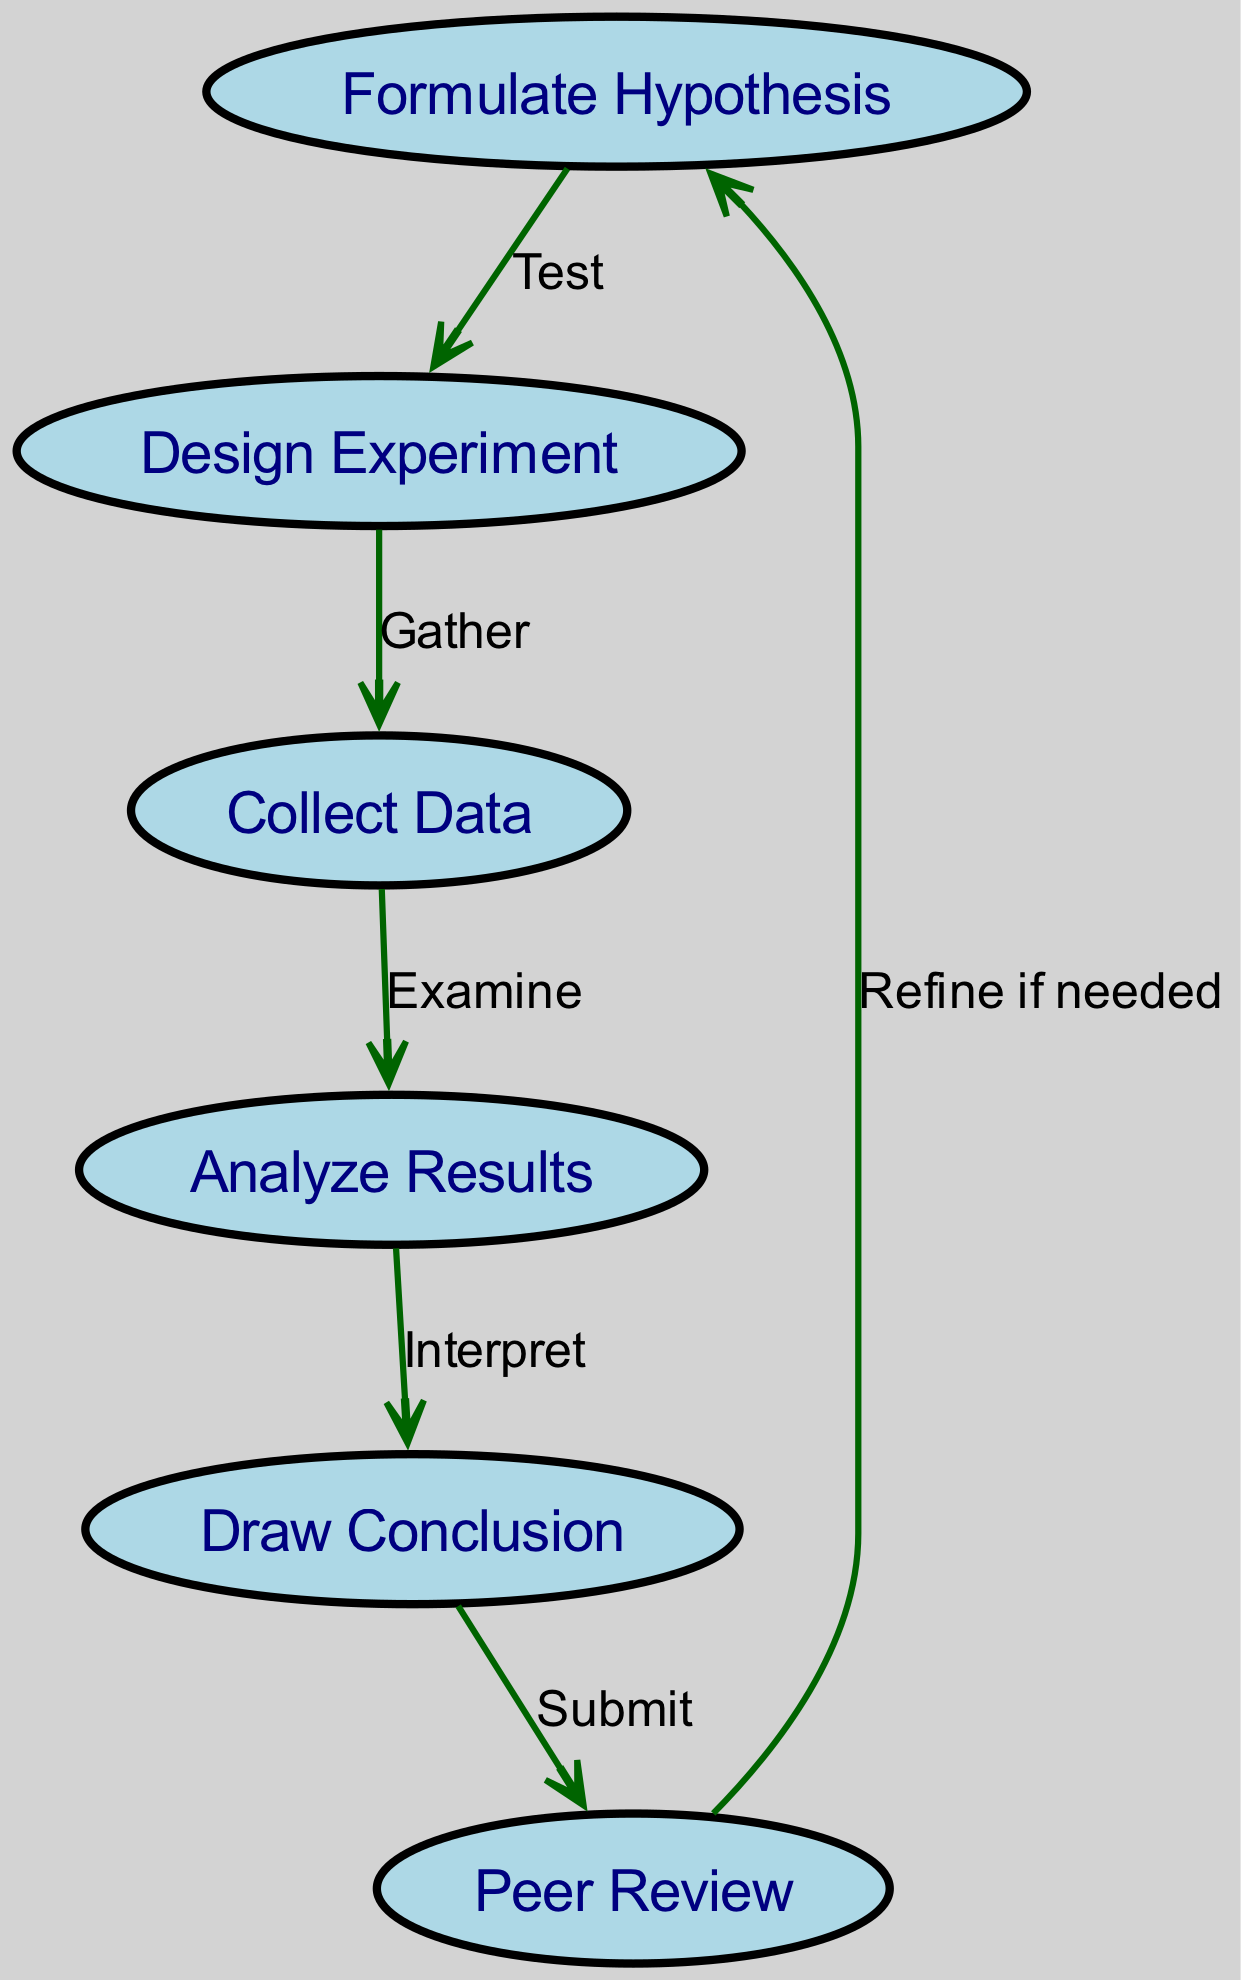What is the first step in the scientific method according to the diagram? The first step is labeled as "Formulate Hypothesis" in the diagram, which is the initial action taken in the scientific method process.
Answer: Formulate Hypothesis How many nodes are present in the diagram? The diagram contains six nodes, as counted from the list provided, which are: Formulate Hypothesis, Design Experiment, Collect Data, Analyze Results, Draw Conclusion, and Peer Review.
Answer: Six What is the label for the node that collects data? The node that collects data is specifically labeled "Collect Data" in the diagram, indicating the action of gathering empirical evidence.
Answer: Collect Data What follows the "Analyze Results" step? The step that follows "Analyze Results" is "Draw Conclusion," representing the process of interpreting the data analysis outcomes.
Answer: Draw Conclusion What relationship exists between "Peer Review" and "Formulate Hypothesis"? The relationship is one of refinement, denoted by the edge labeled "Refine if needed," indicating that peer review can lead back to revising the original hypothesis based on feedback.
Answer: Refine if needed How many edges are there in the diagram? There are five edges represented in the diagram, connecting the various steps of the scientific method and indicating the flow of the process.
Answer: Five What step comes after "Design Experiment"? The step that comes after "Design Experiment" is "Collect Data," which involves the gathering of information to test the hypothesis formulated.
Answer: Collect Data What action is indicated by the edge between "Conclusion" and "Review"? The edge indicates the action "Submit," which denotes that a conclusion should be submitted for peer review after it has been drawn.
Answer: Submit Which step involves data examination? The step involving data examination is labeled "Analyze Results," which represents the process of evaluating the collected data to gain insights.
Answer: Analyze Results 